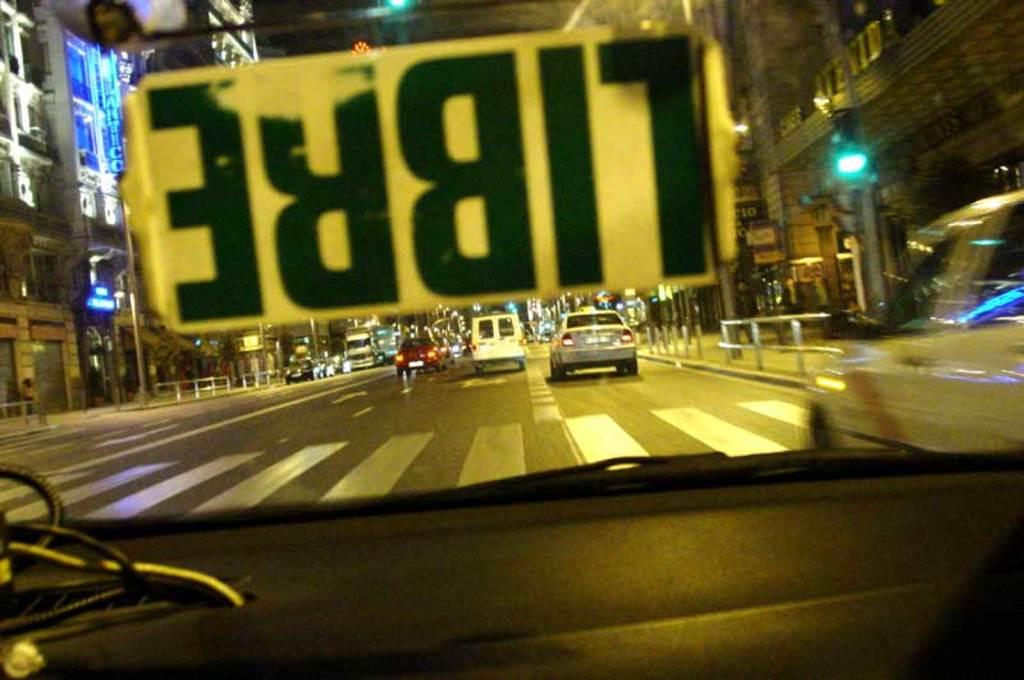<image>
Give a short and clear explanation of the subsequent image. An upside-down sign in a car windshield says "libre" on it. 